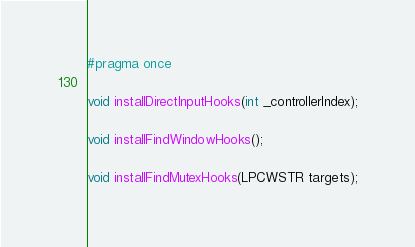Convert code to text. <code><loc_0><loc_0><loc_500><loc_500><_C_>#pragma once

void installDirectInputHooks(int _controllerIndex);

void installFindWindowHooks();

void installFindMutexHooks(LPCWSTR targets);</code> 